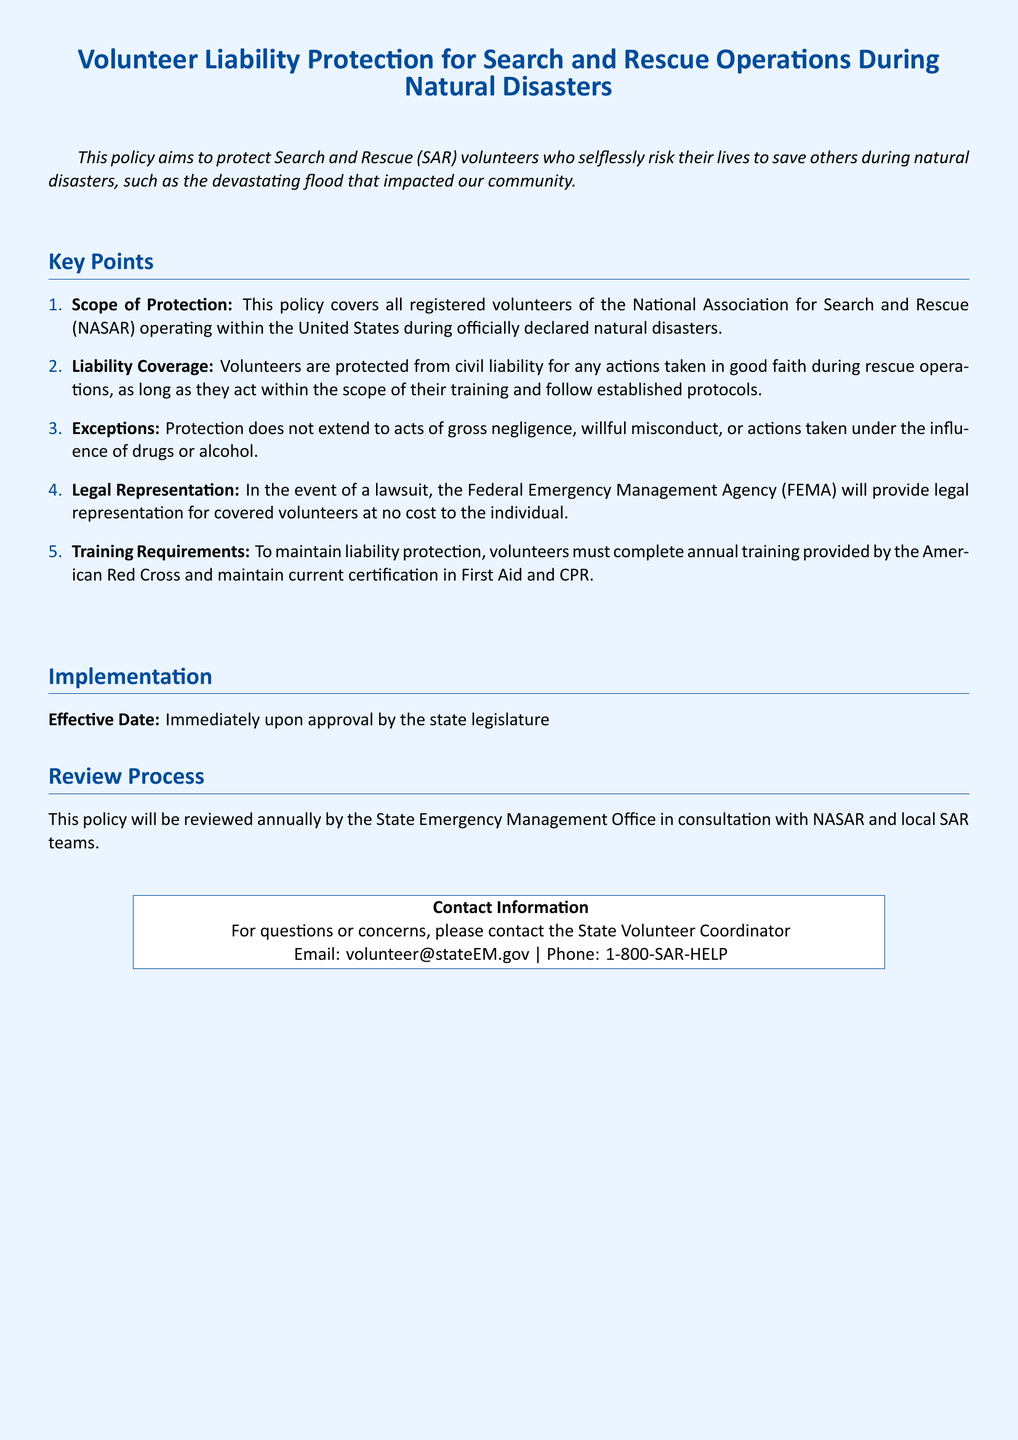What is the effective date of the policy? The effective date is mentioned as "Immediately upon approval by the state legislature."
Answer: Immediately upon approval by the state legislature Who provides legal representation for volunteers? The document states that "the Federal Emergency Management Agency (FEMA) will provide legal representation."
Answer: Federal Emergency Management Agency (FEMA) What is covered under the liability protection? The document specifies that volunteers are protected from civil liability for actions taken in good faith during rescue operations.
Answer: Actions taken in good faith during rescue operations What is the annual training requirement mentioned? The policy outlines that "volunteers must complete annual training provided by the American Red Cross."
Answer: Annual training provided by the American Red Cross Which organization must volunteers be registered with? The policy indicates that volunteers must be registered with "the National Association for Search and Rescue (NASAR)."
Answer: National Association for Search and Rescue (NASAR) What type of misconduct is not protected under this policy? The document lists "gross negligence" as an exception to the protection provided to volunteers.
Answer: Gross negligence How often will the policy be reviewed? The review frequency is stated to be "annually by the State Emergency Management Office."
Answer: Annually What is required to maintain liability protection? The document mentions that maintaining current certification in First Aid and CPR is required.
Answer: Current certification in First Aid and CPR What type of document is this? This document is a "Volunteer Liability Protection policy."
Answer: Volunteer Liability Protection policy 